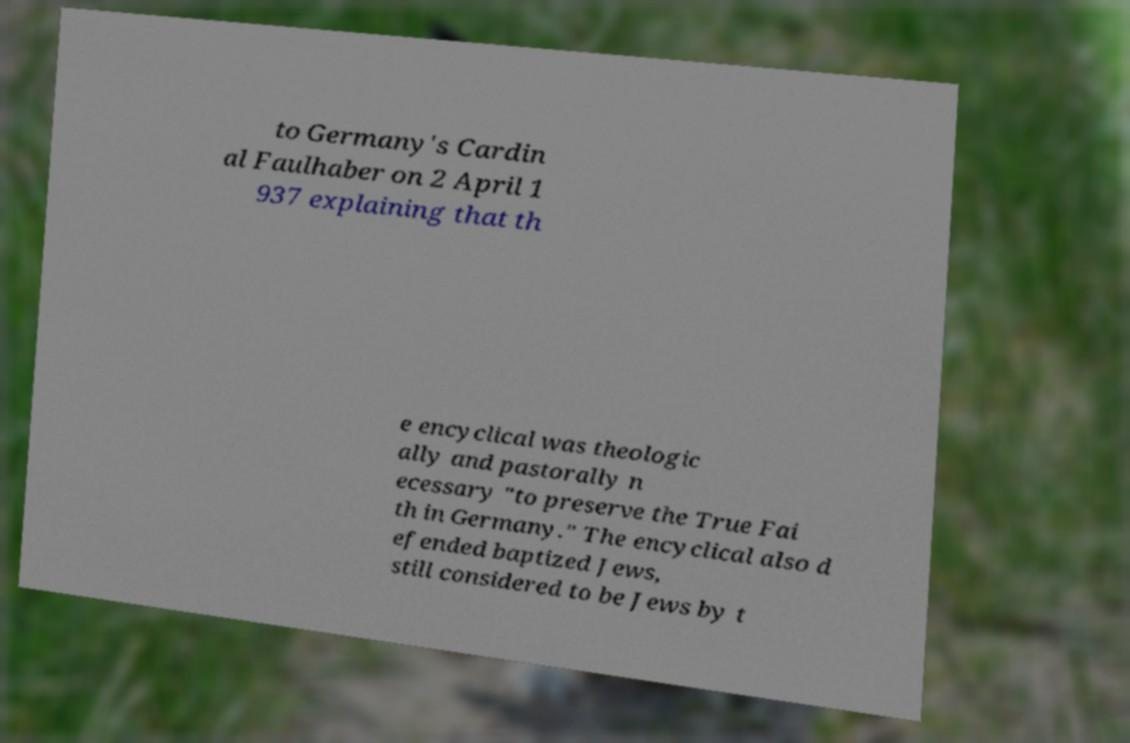I need the written content from this picture converted into text. Can you do that? to Germany's Cardin al Faulhaber on 2 April 1 937 explaining that th e encyclical was theologic ally and pastorally n ecessary "to preserve the True Fai th in Germany." The encyclical also d efended baptized Jews, still considered to be Jews by t 